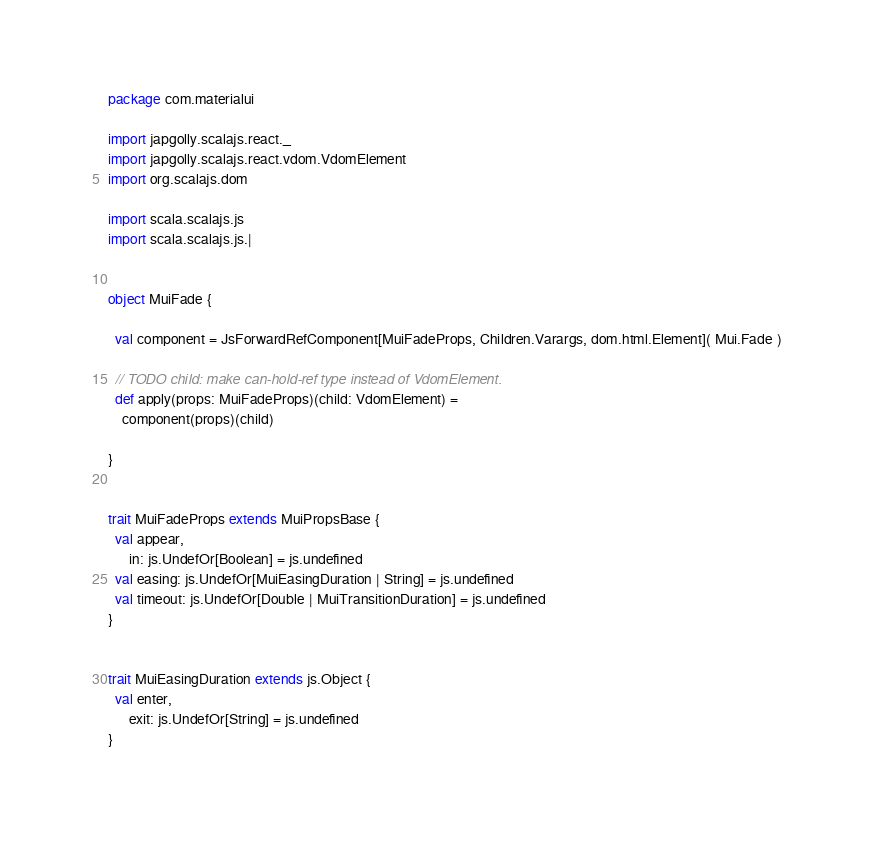<code> <loc_0><loc_0><loc_500><loc_500><_Scala_>package com.materialui

import japgolly.scalajs.react._
import japgolly.scalajs.react.vdom.VdomElement
import org.scalajs.dom

import scala.scalajs.js
import scala.scalajs.js.|


object MuiFade {

  val component = JsForwardRefComponent[MuiFadeProps, Children.Varargs, dom.html.Element]( Mui.Fade )

  // TODO child: make can-hold-ref type instead of VdomElement.
  def apply(props: MuiFadeProps)(child: VdomElement) =
    component(props)(child)

}


trait MuiFadeProps extends MuiPropsBase {
  val appear,
      in: js.UndefOr[Boolean] = js.undefined
  val easing: js.UndefOr[MuiEasingDuration | String] = js.undefined
  val timeout: js.UndefOr[Double | MuiTransitionDuration] = js.undefined
}


trait MuiEasingDuration extends js.Object {
  val enter,
      exit: js.UndefOr[String] = js.undefined
}


</code> 